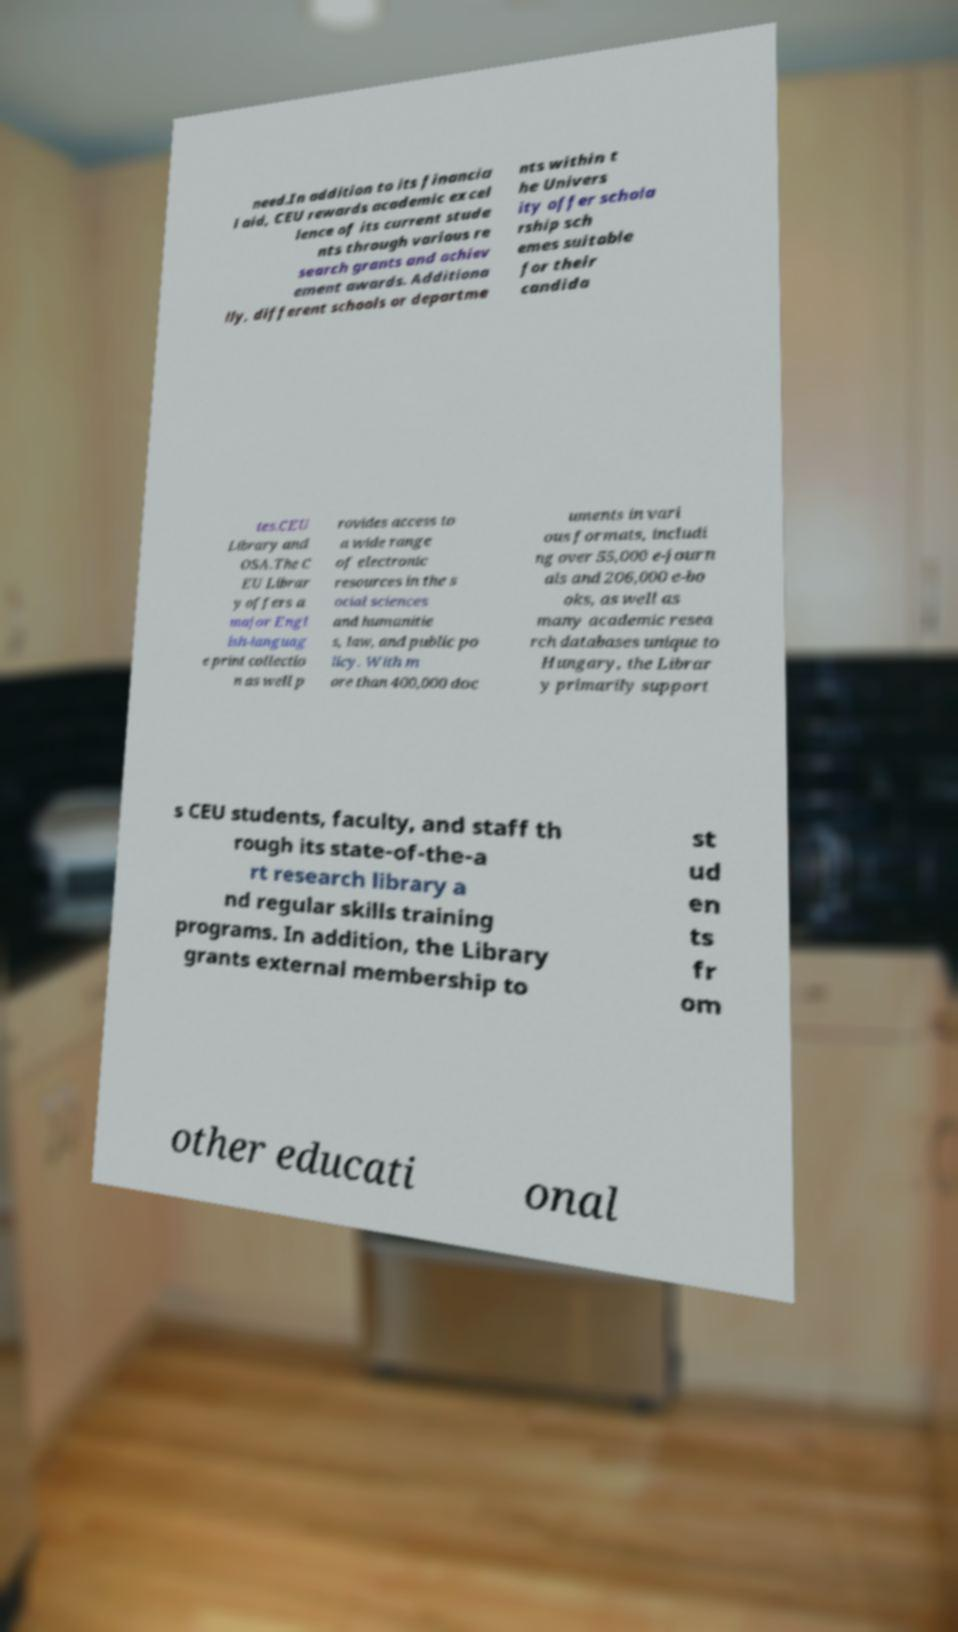Can you read and provide the text displayed in the image?This photo seems to have some interesting text. Can you extract and type it out for me? need.In addition to its financia l aid, CEU rewards academic excel lence of its current stude nts through various re search grants and achiev ement awards. Additiona lly, different schools or departme nts within t he Univers ity offer schola rship sch emes suitable for their candida tes.CEU Library and OSA.The C EU Librar y offers a major Engl ish-languag e print collectio n as well p rovides access to a wide range of electronic resources in the s ocial sciences and humanitie s, law, and public po licy. With m ore than 400,000 doc uments in vari ous formats, includi ng over 55,000 e-journ als and 206,000 e-bo oks, as well as many academic resea rch databases unique to Hungary, the Librar y primarily support s CEU students, faculty, and staff th rough its state-of-the-a rt research library a nd regular skills training programs. In addition, the Library grants external membership to st ud en ts fr om other educati onal 